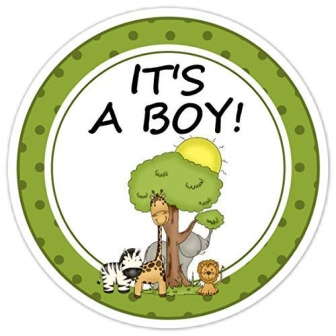Imagine this scene as part of an animated children's show. What might happen next? As the scene opens, the camera zooms in on the cheerful gathering announced by the 'IT'S A BOY!' sticker. Suddenly, the baby boy, a tiny lion cub, scampers into the picture, curious and full of energy. Giraffe offers him a ride on his back, while Zebra and Lion organize a playful parade. The yellow bird sings a welcome melody as they all embark on a joyful adventure through the savanna, discovering new friends and learning important life lessons along the way. Each episode brings new fun, laughter, and educational messages about friendship, family, and the beauty of nature. 